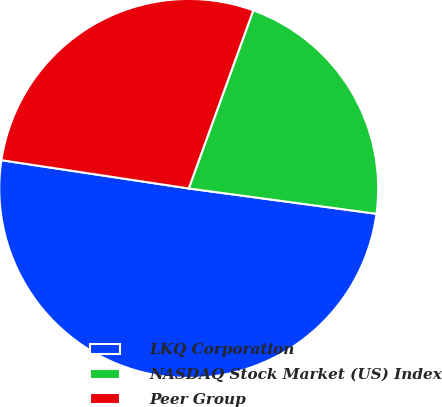<chart> <loc_0><loc_0><loc_500><loc_500><pie_chart><fcel>LKQ Corporation<fcel>NASDAQ Stock Market (US) Index<fcel>Peer Group<nl><fcel>50.25%<fcel>21.6%<fcel>28.15%<nl></chart> 